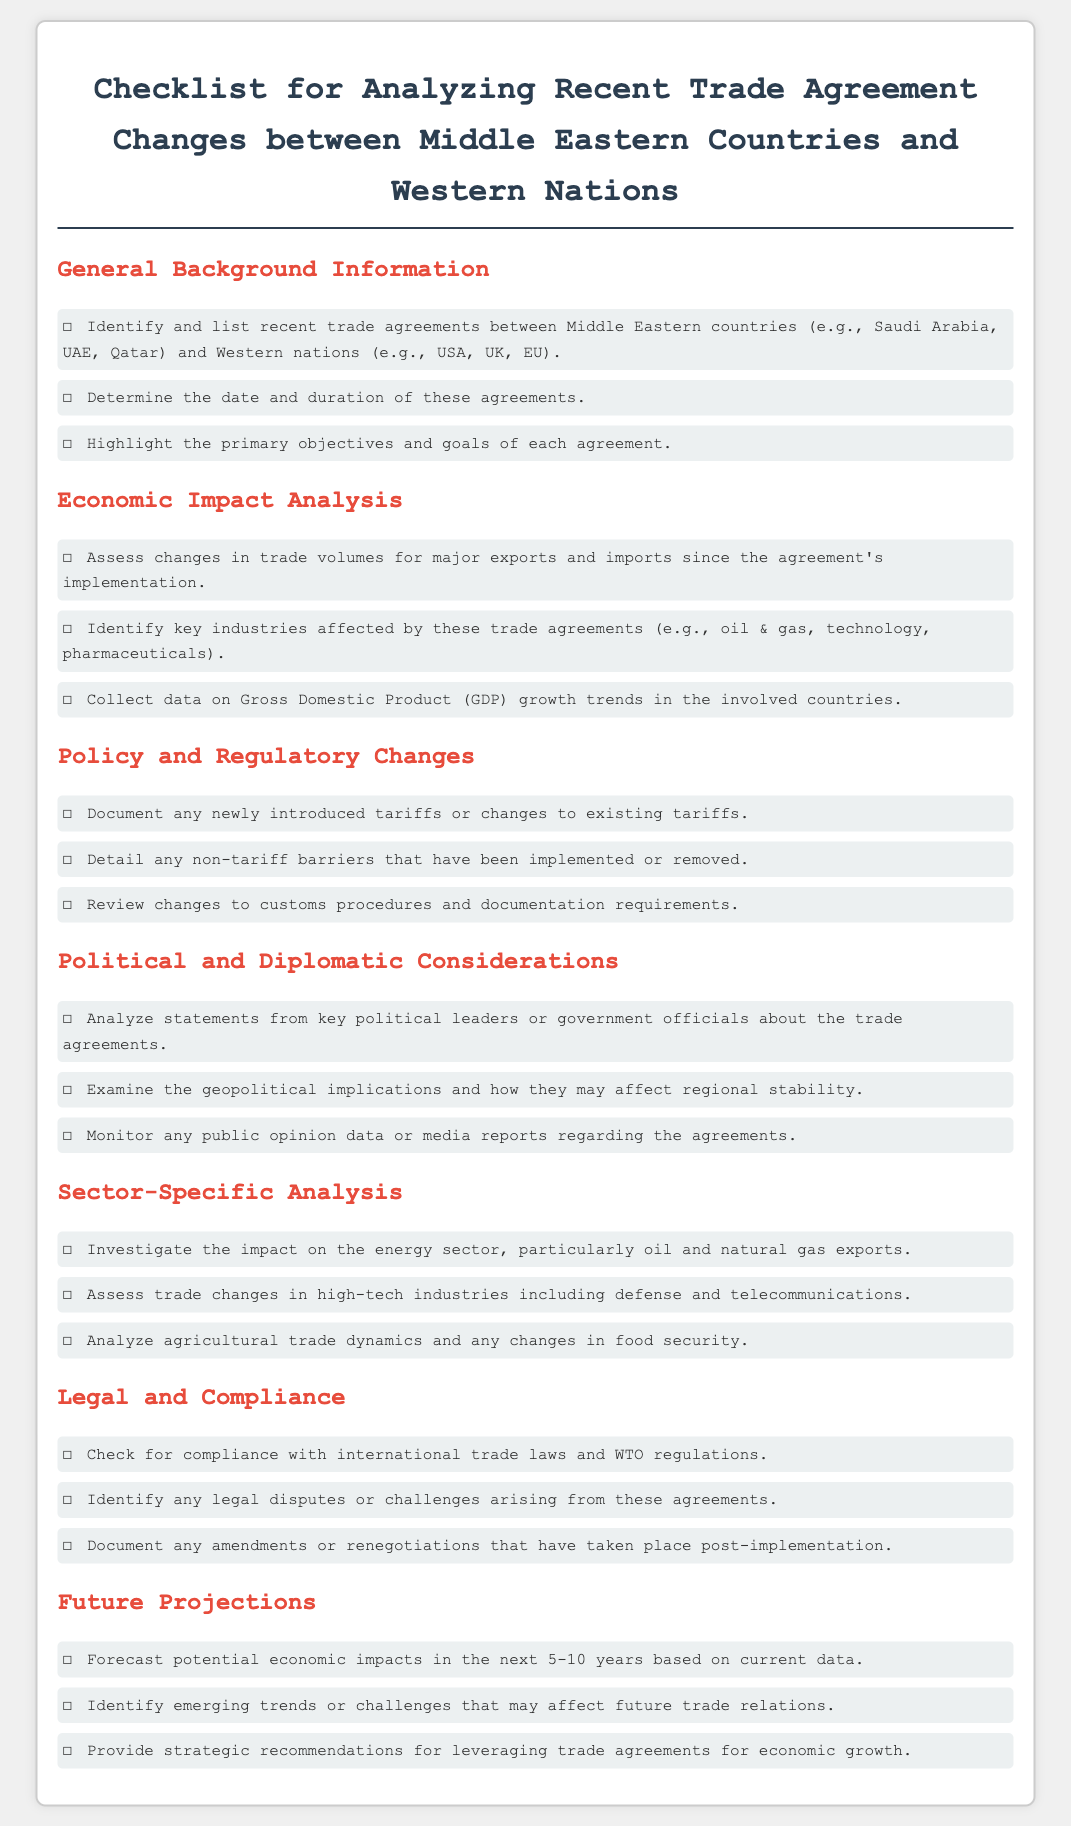what are some recent trade agreements between Middle Eastern countries and Western nations? The document lists specific countries involved in recent trade agreements, including Saudi Arabia, UAE, and Qatar in the Middle East, and USA, UK, and EU as Western nations.
Answer: Saudi Arabia, UAE, Qatar, USA, UK, EU what is the focus of sector-specific analysis? The section describes specific areas of trade that need to be investigated, including the energy sector, high-tech industries, and agricultural trade dynamics.
Answer: energy sector, high-tech industries, agricultural trade dynamics when should the economic impacts of trade agreements be forecasted? The checklist mentions that potential economic impacts should be forecasted in the next 5-10 years.
Answer: 5-10 years what type of barriers are documented in policy and regulatory changes? The document specifies non-tariff barriers that may have been implemented or removed due to recent trade agreements.
Answer: non-tariff barriers how are political and diplomatic considerations evaluated according to the checklist? The checklist states that statements from key political leaders or government officials regarding the trade agreements are analyzed along with geopolitical implications.
Answer: statements, geopolitical implications 